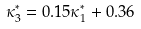<formula> <loc_0><loc_0><loc_500><loc_500>\kappa _ { 3 } ^ { * } = 0 . 1 5 \kappa _ { 1 } ^ { * } + 0 . 3 6</formula> 